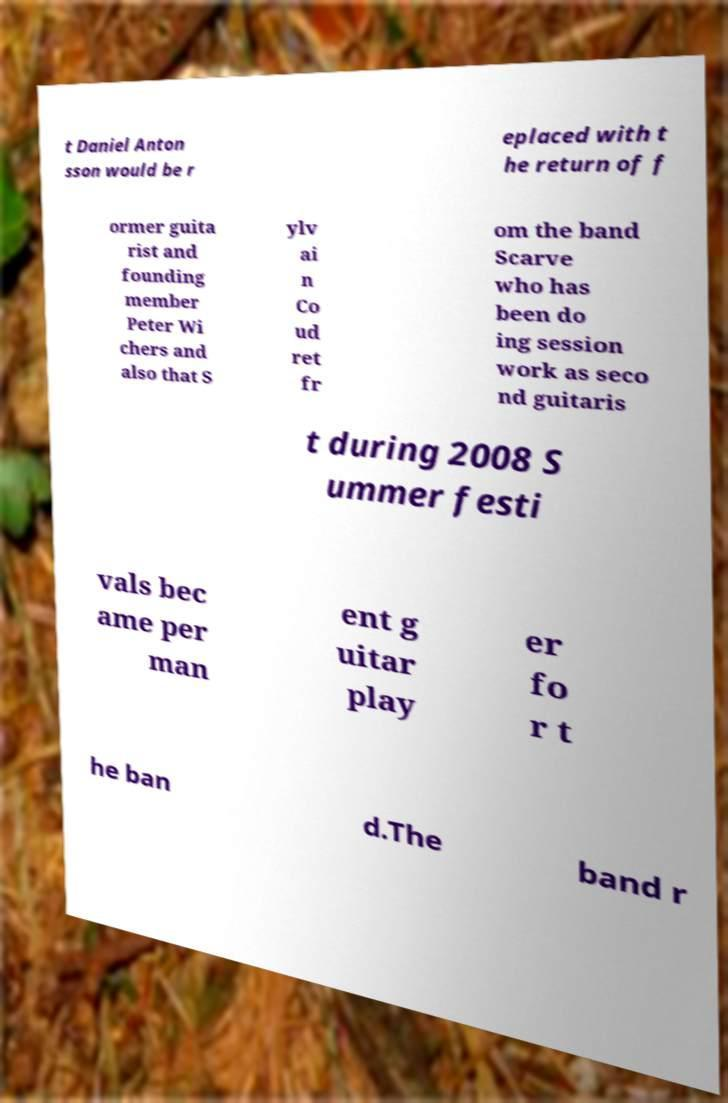I need the written content from this picture converted into text. Can you do that? t Daniel Anton sson would be r eplaced with t he return of f ormer guita rist and founding member Peter Wi chers and also that S ylv ai n Co ud ret fr om the band Scarve who has been do ing session work as seco nd guitaris t during 2008 S ummer festi vals bec ame per man ent g uitar play er fo r t he ban d.The band r 